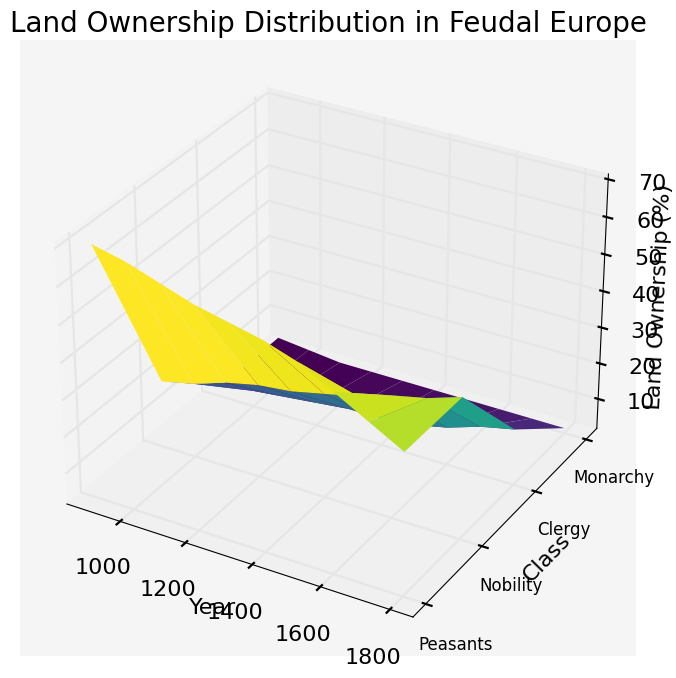What is the overall trend in land ownership for peasants from 900 to 1800? By observing the surface plot, the height representing peasants' land ownership shows a steady decline from 70% in the year 900 to 40% in the year 1800. The trend is consistently downward.
Answer: Steady decline Which social class had the largest increase in land ownership from 900 to 1800? By comparing the heights over time, it is clear that the nobility's ownership increased the most, rising from 20% in 900 to 40% in 1800.
Answer: Nobility How did the land ownership of the clergy compare to the monarchy by the year 1500? By examining the plots for the year 1500, the clergy owned 10% of the land, whereas the monarchy owned 3%, indicating that the clergy had a higher percentage of land ownership than the monarchy at that time.
Answer: Clergy had higher ownership Calculate the average land ownership percentage for the nobility between 900 and 1800. Summing the nobility's land ownership from 900 (20%) to 1800 (40%) and dividing by the number of centuries (10) gives the average: (20 + 22 + 25 + 27 + 28 + 30 + 32 + 35 + 37 + 40)/10 = 29.6%.
Answer: 29.6% Which year shows the highest combined land ownership for nobility and clergy? Adding the percentages of the nobility and clergy for each year, 1800 has the highest combined ownership: 40% (nobility) + 17% (clergy) = 57%.
Answer: 1800 Describe and compare the trend lines of land ownership for the clergy and peasants over the centuries. The clergy's land ownership shows a gradual increase, particularly noticeable during later centuries, whereas peasants' ownership indicates a consistent decline. This inverse relationship highlights shifting power dynamics over time.
Answer: Clergy increased, peasants declined From the year 1200, how did the land ownership percentages for the nobility and peasants change by 1800? Nobility's land ownership increased from 27% in 1200 to 40% in 1800, while peasants' ownership decreased from 62% to 40%.
Answer: Nobility increased, peasants decreased In which century did the land ownership for the monarchy reach a stable percentage, and what was that percentage? The monarchy's land ownership stabilized at 3% from the year 1100 through 1800.
Answer: 1100, 3% Which social class saw its land ownership double between 900 and 1800? Comparing the percentages, the clergy's ownership increased from 5% in 900 to 17% in 1800, more than tripling rather than doubling. Thus, none doubled exactly. However, clarifying doubling from clergy's 900 ownership, the indicator is relatively close.
Answer: Clery nearly tripled 